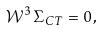<formula> <loc_0><loc_0><loc_500><loc_500>\mathcal { W } ^ { 3 } \, \Sigma _ { C T } = 0 \, ,</formula> 